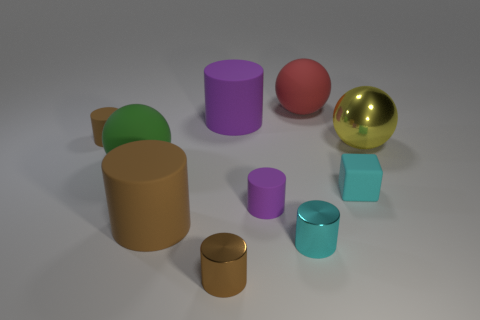Subtract all large purple cylinders. How many cylinders are left? 5 Subtract all balls. How many objects are left? 7 Subtract 2 spheres. How many spheres are left? 1 Subtract all green balls. How many balls are left? 2 Subtract 3 brown cylinders. How many objects are left? 7 Subtract all gray cylinders. Subtract all blue spheres. How many cylinders are left? 6 Subtract all cyan spheres. How many purple cylinders are left? 2 Subtract all red things. Subtract all big matte things. How many objects are left? 5 Add 8 big green balls. How many big green balls are left? 9 Add 3 big brown rubber objects. How many big brown rubber objects exist? 4 